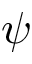Convert formula to latex. <formula><loc_0><loc_0><loc_500><loc_500>\psi</formula> 